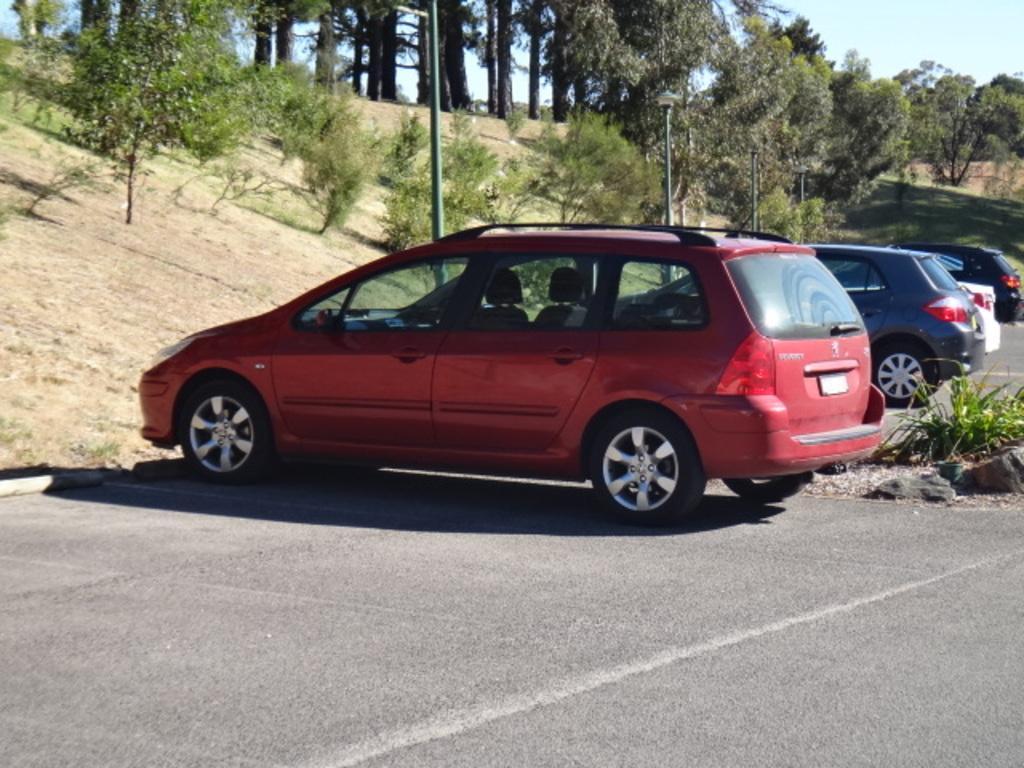Could you give a brief overview of what you see in this image? In this image I can see a road in the front and on it I can see four cars. I can also see a plant on the right side of the image. In the background I can see number of poles, number of trees and the sky. 